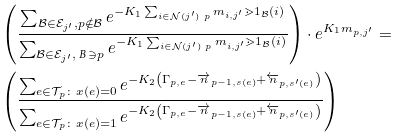Convert formula to latex. <formula><loc_0><loc_0><loc_500><loc_500>& \left ( \frac { \sum _ { \mathcal { B } \in \mathcal { E } _ { j ^ { \prime } } , p \notin \mathcal { B } } e ^ { - K _ { 1 } \sum _ { i \in \mathcal { N } ( j ^ { \prime } ) \ p } m _ { i , j ^ { \prime } } \mathbb { m } { 1 } _ { \mathcal { B } } ( i ) } } { \sum _ { \mathcal { B } \in \mathcal { E } _ { j ^ { \prime } } , \emph { B } \ni p } e ^ { - K _ { 1 } \sum _ { i \in \mathcal { N } ( j ^ { \prime } ) \ p } m _ { i , j ^ { \prime } } \mathbb { m } { 1 } _ { \mathcal { B } } ( i ) } } \right ) \cdot e ^ { K _ { 1 } m _ { p , j ^ { \prime } } } = \\ & \left ( \frac { \sum _ { e \in \mathcal { T } _ { p } \colon x ( e ) = 0 } e ^ { - K _ { 2 } \left ( \Gamma _ { p , e } - \overrightarrow { n } _ { p - 1 , s ( e ) } + \overleftarrow { n } _ { p , s ^ { \prime } ( e ) } \right ) } } { \sum _ { e \in \mathcal { T } _ { p } \colon x ( e ) = 1 } e ^ { - K _ { 2 } \left ( \Gamma _ { p , e } - \overrightarrow { n } _ { p - 1 , s ( e ) } + \overleftarrow { n } _ { p , s ^ { \prime } ( e ) } \right ) } } \right )</formula> 